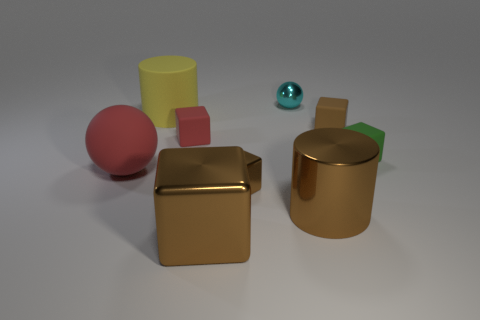There is a small cyan thing; does it have the same shape as the object to the left of the large yellow rubber cylinder?
Your answer should be very brief. Yes. Is the number of tiny green rubber cubes in front of the big red rubber ball less than the number of tiny rubber cubes on the right side of the small metallic block?
Keep it short and to the point. Yes. Do the cyan thing and the big red thing have the same shape?
Ensure brevity in your answer.  Yes. How big is the cyan metal sphere?
Your answer should be compact. Small. There is a rubber thing that is to the left of the tiny brown rubber cube and to the right of the yellow thing; what color is it?
Your response must be concise. Red. Are there more cyan shiny spheres than yellow metallic things?
Your answer should be compact. Yes. What number of objects are either matte things or blocks that are in front of the tiny brown matte cube?
Give a very brief answer. 7. Do the cyan thing and the matte cylinder have the same size?
Your answer should be very brief. No. Are there any large objects behind the red matte ball?
Your answer should be very brief. Yes. What is the size of the rubber thing that is both on the left side of the tiny red matte object and in front of the matte cylinder?
Give a very brief answer. Large. 